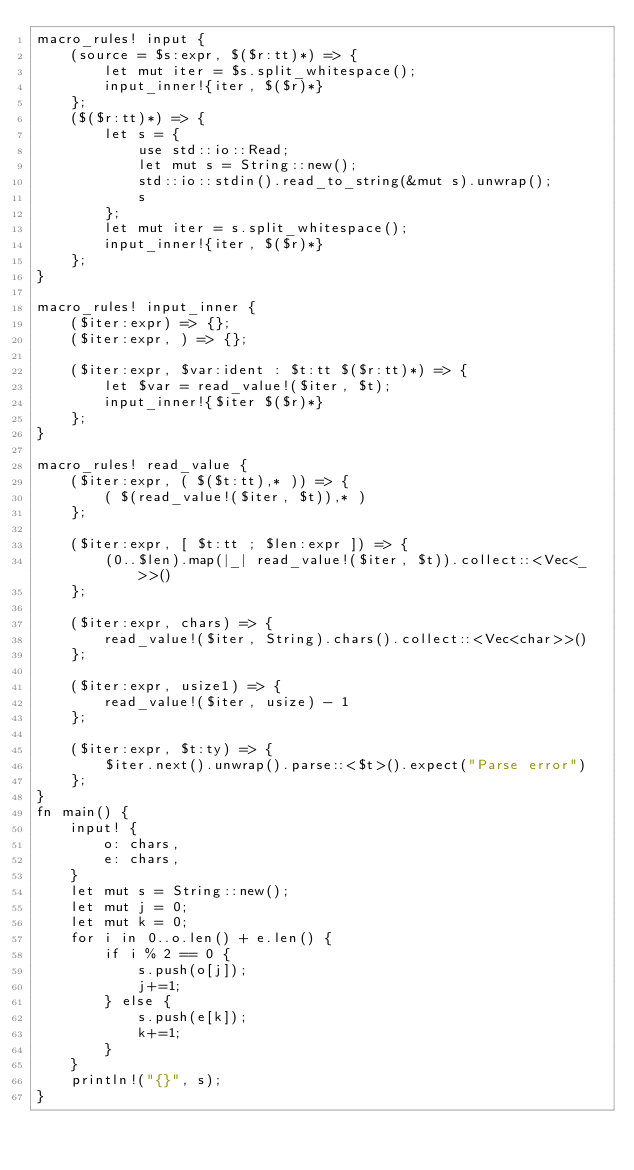<code> <loc_0><loc_0><loc_500><loc_500><_Rust_>macro_rules! input {
    (source = $s:expr, $($r:tt)*) => {
        let mut iter = $s.split_whitespace();
        input_inner!{iter, $($r)*}
    };
    ($($r:tt)*) => {
        let s = {
            use std::io::Read;
            let mut s = String::new();
            std::io::stdin().read_to_string(&mut s).unwrap();
            s
        };
        let mut iter = s.split_whitespace();
        input_inner!{iter, $($r)*}
    };
}

macro_rules! input_inner {
    ($iter:expr) => {};
    ($iter:expr, ) => {};

    ($iter:expr, $var:ident : $t:tt $($r:tt)*) => {
        let $var = read_value!($iter, $t);
        input_inner!{$iter $($r)*}
    };
}

macro_rules! read_value {
    ($iter:expr, ( $($t:tt),* )) => {
        ( $(read_value!($iter, $t)),* )
    };

    ($iter:expr, [ $t:tt ; $len:expr ]) => {
        (0..$len).map(|_| read_value!($iter, $t)).collect::<Vec<_>>()
    };

    ($iter:expr, chars) => {
        read_value!($iter, String).chars().collect::<Vec<char>>()
    };

    ($iter:expr, usize1) => {
        read_value!($iter, usize) - 1
    };

    ($iter:expr, $t:ty) => {
        $iter.next().unwrap().parse::<$t>().expect("Parse error")
    };
}
fn main() {
    input! {
        o: chars,
        e: chars,
    }
    let mut s = String::new();
    let mut j = 0;
    let mut k = 0;
    for i in 0..o.len() + e.len() {
        if i % 2 == 0 {
            s.push(o[j]);
            j+=1;
        } else {
            s.push(e[k]);
            k+=1;
        }
    }
    println!("{}", s);
}</code> 